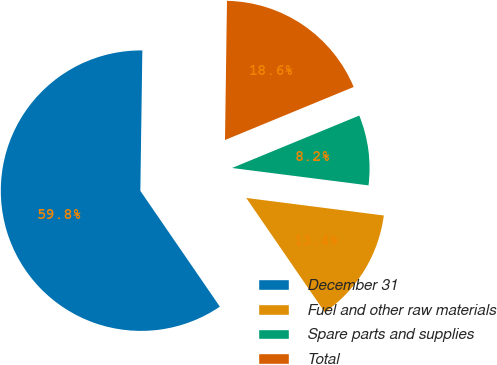Convert chart to OTSL. <chart><loc_0><loc_0><loc_500><loc_500><pie_chart><fcel>December 31<fcel>Fuel and other raw materials<fcel>Spare parts and supplies<fcel>Total<nl><fcel>59.8%<fcel>13.4%<fcel>8.24%<fcel>18.55%<nl></chart> 